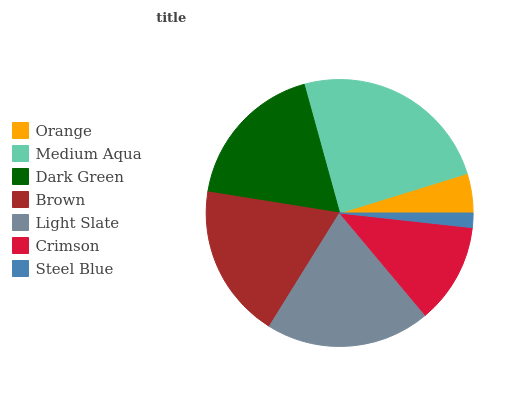Is Steel Blue the minimum?
Answer yes or no. Yes. Is Medium Aqua the maximum?
Answer yes or no. Yes. Is Dark Green the minimum?
Answer yes or no. No. Is Dark Green the maximum?
Answer yes or no. No. Is Medium Aqua greater than Dark Green?
Answer yes or no. Yes. Is Dark Green less than Medium Aqua?
Answer yes or no. Yes. Is Dark Green greater than Medium Aqua?
Answer yes or no. No. Is Medium Aqua less than Dark Green?
Answer yes or no. No. Is Dark Green the high median?
Answer yes or no. Yes. Is Dark Green the low median?
Answer yes or no. Yes. Is Light Slate the high median?
Answer yes or no. No. Is Crimson the low median?
Answer yes or no. No. 